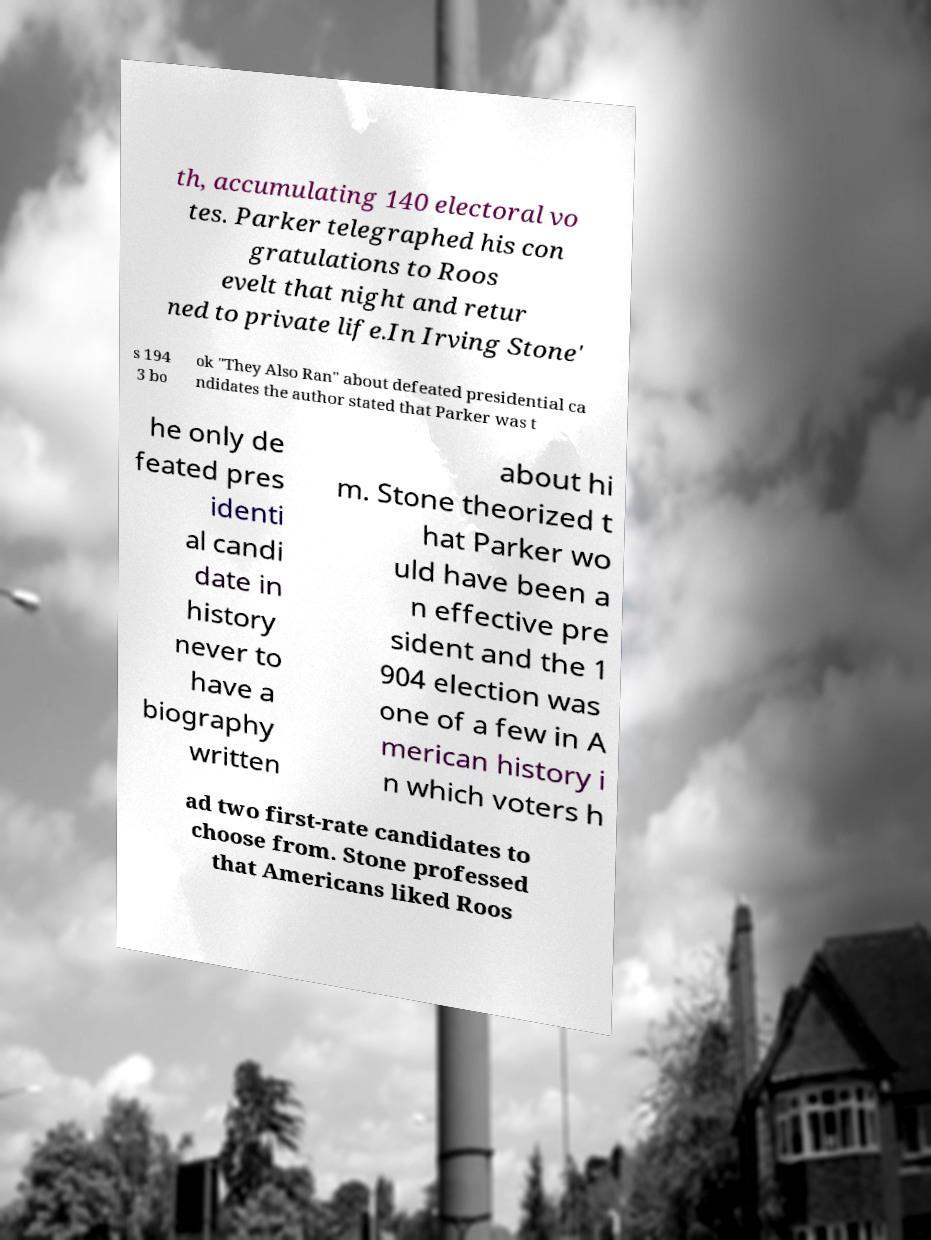For documentation purposes, I need the text within this image transcribed. Could you provide that? th, accumulating 140 electoral vo tes. Parker telegraphed his con gratulations to Roos evelt that night and retur ned to private life.In Irving Stone' s 194 3 bo ok "They Also Ran" about defeated presidential ca ndidates the author stated that Parker was t he only de feated pres identi al candi date in history never to have a biography written about hi m. Stone theorized t hat Parker wo uld have been a n effective pre sident and the 1 904 election was one of a few in A merican history i n which voters h ad two first-rate candidates to choose from. Stone professed that Americans liked Roos 